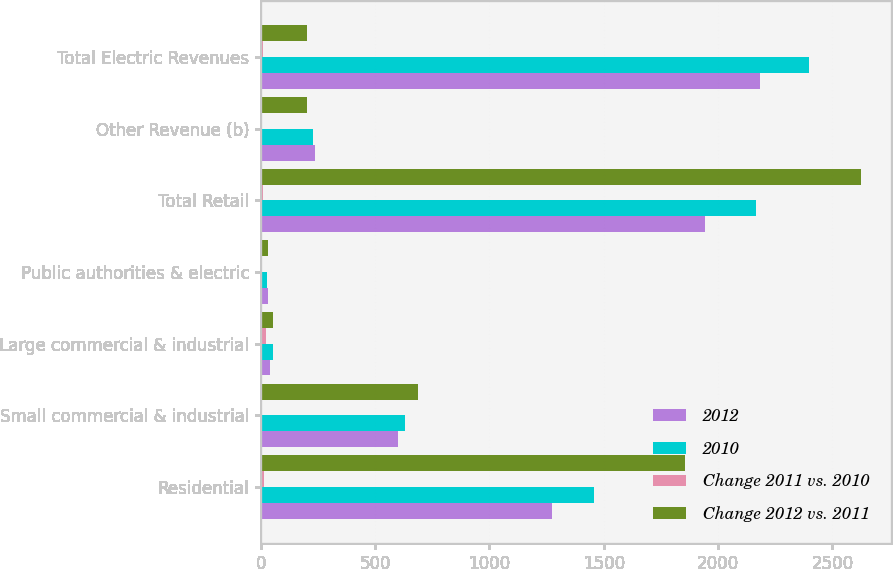Convert chart. <chart><loc_0><loc_0><loc_500><loc_500><stacked_bar_chart><ecel><fcel>Residential<fcel>Small commercial & industrial<fcel>Large commercial & industrial<fcel>Public authorities & electric<fcel>Total Retail<fcel>Other Revenue (b)<fcel>Total Electric Revenues<nl><fcel>2012<fcel>1274<fcel>600<fcel>40<fcel>30<fcel>1944<fcel>239<fcel>2183<nl><fcel>2010<fcel>1456<fcel>632<fcel>51<fcel>29<fcel>2168<fcel>228<fcel>2396<nl><fcel>Change 2011 vs. 2010<fcel>12.5<fcel>5.1<fcel>21.6<fcel>3.4<fcel>10.3<fcel>4.8<fcel>8.9<nl><fcel>Change 2012 vs. 2011<fcel>1857<fcel>687<fcel>53<fcel>30<fcel>2627<fcel>204<fcel>204<nl></chart> 